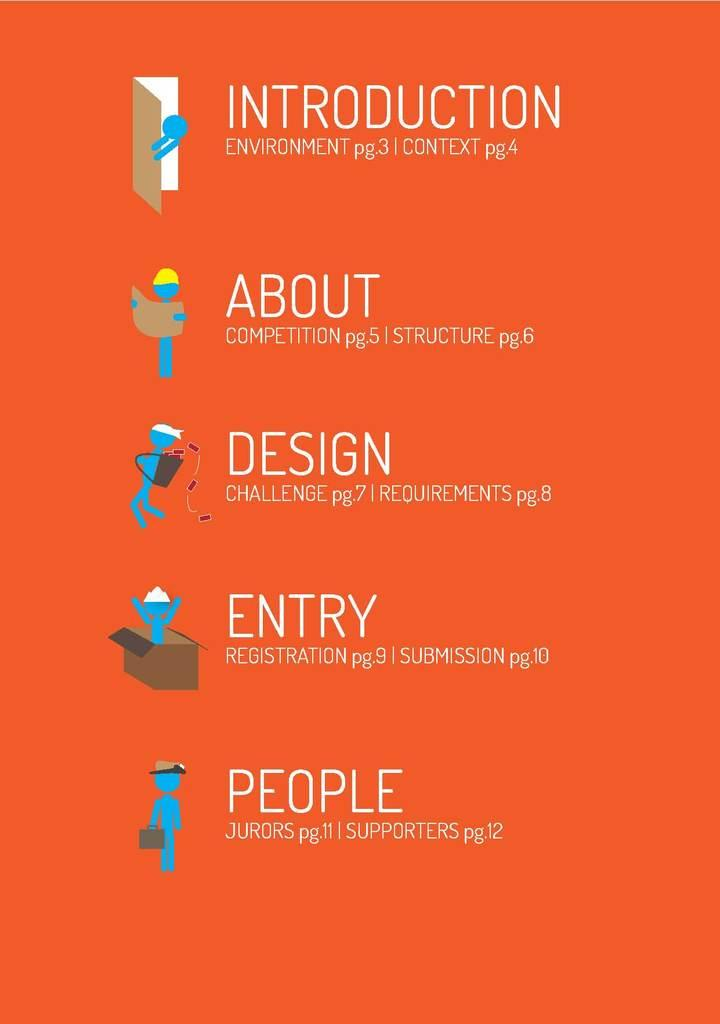Provide a one-sentence caption for the provided image. An orange and very decorated content page with icons. 